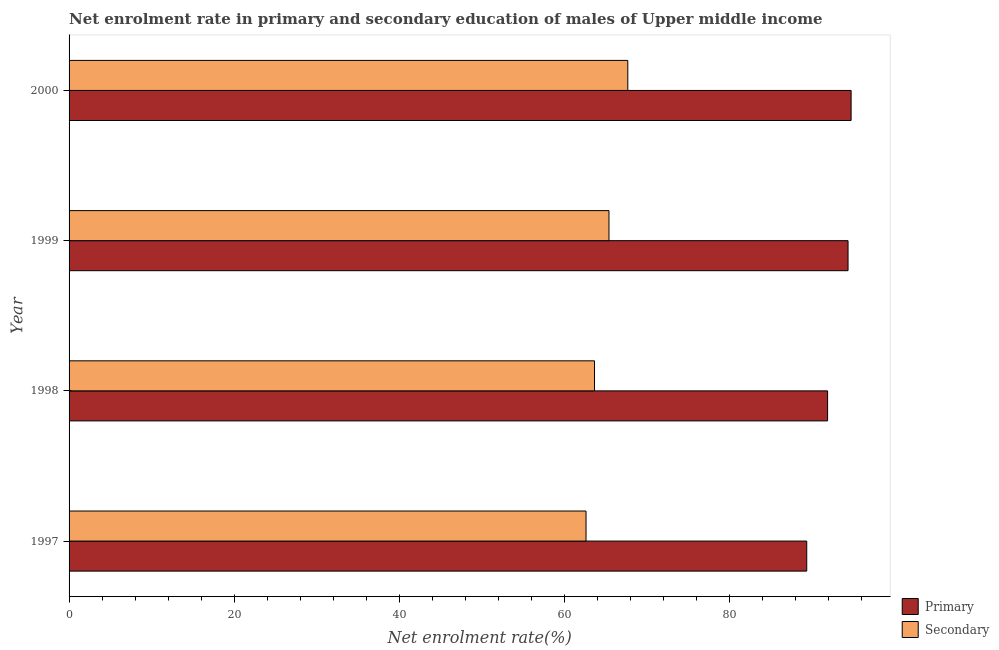How many different coloured bars are there?
Provide a short and direct response. 2. Are the number of bars per tick equal to the number of legend labels?
Provide a succinct answer. Yes. How many bars are there on the 3rd tick from the bottom?
Offer a very short reply. 2. What is the label of the 2nd group of bars from the top?
Make the answer very short. 1999. What is the enrollment rate in secondary education in 1998?
Your answer should be compact. 63.63. Across all years, what is the maximum enrollment rate in secondary education?
Give a very brief answer. 67.66. Across all years, what is the minimum enrollment rate in secondary education?
Provide a succinct answer. 62.6. In which year was the enrollment rate in primary education maximum?
Your answer should be compact. 2000. What is the total enrollment rate in primary education in the graph?
Your response must be concise. 370.21. What is the difference between the enrollment rate in primary education in 1998 and that in 2000?
Provide a succinct answer. -2.85. What is the difference between the enrollment rate in primary education in 2000 and the enrollment rate in secondary education in 1999?
Give a very brief answer. 29.32. What is the average enrollment rate in secondary education per year?
Give a very brief answer. 64.82. In the year 1998, what is the difference between the enrollment rate in secondary education and enrollment rate in primary education?
Provide a short and direct response. -28.22. In how many years, is the enrollment rate in secondary education greater than 20 %?
Provide a succinct answer. 4. Is the enrollment rate in primary education in 1998 less than that in 1999?
Your answer should be very brief. Yes. What is the difference between the highest and the second highest enrollment rate in primary education?
Your response must be concise. 0.37. What is the difference between the highest and the lowest enrollment rate in secondary education?
Your answer should be compact. 5.06. What does the 1st bar from the top in 1999 represents?
Your answer should be compact. Secondary. What does the 2nd bar from the bottom in 1999 represents?
Ensure brevity in your answer.  Secondary. How many years are there in the graph?
Your answer should be very brief. 4. What is the difference between two consecutive major ticks on the X-axis?
Keep it short and to the point. 20. Are the values on the major ticks of X-axis written in scientific E-notation?
Your answer should be compact. No. Does the graph contain any zero values?
Ensure brevity in your answer.  No. Where does the legend appear in the graph?
Offer a terse response. Bottom right. How are the legend labels stacked?
Provide a succinct answer. Vertical. What is the title of the graph?
Give a very brief answer. Net enrolment rate in primary and secondary education of males of Upper middle income. What is the label or title of the X-axis?
Your answer should be very brief. Net enrolment rate(%). What is the Net enrolment rate(%) in Primary in 1997?
Your response must be concise. 89.33. What is the Net enrolment rate(%) of Secondary in 1997?
Make the answer very short. 62.6. What is the Net enrolment rate(%) in Primary in 1998?
Give a very brief answer. 91.85. What is the Net enrolment rate(%) in Secondary in 1998?
Offer a very short reply. 63.63. What is the Net enrolment rate(%) of Primary in 1999?
Offer a very short reply. 94.33. What is the Net enrolment rate(%) in Secondary in 1999?
Give a very brief answer. 65.38. What is the Net enrolment rate(%) in Primary in 2000?
Your answer should be compact. 94.7. What is the Net enrolment rate(%) of Secondary in 2000?
Your response must be concise. 67.66. Across all years, what is the maximum Net enrolment rate(%) in Primary?
Offer a very short reply. 94.7. Across all years, what is the maximum Net enrolment rate(%) of Secondary?
Give a very brief answer. 67.66. Across all years, what is the minimum Net enrolment rate(%) of Primary?
Your answer should be compact. 89.33. Across all years, what is the minimum Net enrolment rate(%) in Secondary?
Keep it short and to the point. 62.6. What is the total Net enrolment rate(%) in Primary in the graph?
Ensure brevity in your answer.  370.21. What is the total Net enrolment rate(%) of Secondary in the graph?
Provide a short and direct response. 259.27. What is the difference between the Net enrolment rate(%) of Primary in 1997 and that in 1998?
Your response must be concise. -2.53. What is the difference between the Net enrolment rate(%) in Secondary in 1997 and that in 1998?
Ensure brevity in your answer.  -1.03. What is the difference between the Net enrolment rate(%) of Primary in 1997 and that in 1999?
Provide a short and direct response. -5. What is the difference between the Net enrolment rate(%) of Secondary in 1997 and that in 1999?
Your answer should be very brief. -2.78. What is the difference between the Net enrolment rate(%) of Primary in 1997 and that in 2000?
Ensure brevity in your answer.  -5.37. What is the difference between the Net enrolment rate(%) in Secondary in 1997 and that in 2000?
Give a very brief answer. -5.06. What is the difference between the Net enrolment rate(%) in Primary in 1998 and that in 1999?
Provide a succinct answer. -2.48. What is the difference between the Net enrolment rate(%) in Secondary in 1998 and that in 1999?
Keep it short and to the point. -1.75. What is the difference between the Net enrolment rate(%) in Primary in 1998 and that in 2000?
Ensure brevity in your answer.  -2.85. What is the difference between the Net enrolment rate(%) in Secondary in 1998 and that in 2000?
Your response must be concise. -4.03. What is the difference between the Net enrolment rate(%) in Primary in 1999 and that in 2000?
Offer a very short reply. -0.37. What is the difference between the Net enrolment rate(%) of Secondary in 1999 and that in 2000?
Provide a short and direct response. -2.28. What is the difference between the Net enrolment rate(%) in Primary in 1997 and the Net enrolment rate(%) in Secondary in 1998?
Your answer should be compact. 25.7. What is the difference between the Net enrolment rate(%) of Primary in 1997 and the Net enrolment rate(%) of Secondary in 1999?
Make the answer very short. 23.95. What is the difference between the Net enrolment rate(%) of Primary in 1997 and the Net enrolment rate(%) of Secondary in 2000?
Provide a succinct answer. 21.67. What is the difference between the Net enrolment rate(%) of Primary in 1998 and the Net enrolment rate(%) of Secondary in 1999?
Your answer should be very brief. 26.47. What is the difference between the Net enrolment rate(%) of Primary in 1998 and the Net enrolment rate(%) of Secondary in 2000?
Your answer should be compact. 24.19. What is the difference between the Net enrolment rate(%) in Primary in 1999 and the Net enrolment rate(%) in Secondary in 2000?
Offer a very short reply. 26.67. What is the average Net enrolment rate(%) of Primary per year?
Offer a very short reply. 92.55. What is the average Net enrolment rate(%) of Secondary per year?
Ensure brevity in your answer.  64.82. In the year 1997, what is the difference between the Net enrolment rate(%) of Primary and Net enrolment rate(%) of Secondary?
Offer a terse response. 26.73. In the year 1998, what is the difference between the Net enrolment rate(%) of Primary and Net enrolment rate(%) of Secondary?
Your answer should be very brief. 28.22. In the year 1999, what is the difference between the Net enrolment rate(%) of Primary and Net enrolment rate(%) of Secondary?
Give a very brief answer. 28.95. In the year 2000, what is the difference between the Net enrolment rate(%) in Primary and Net enrolment rate(%) in Secondary?
Give a very brief answer. 27.04. What is the ratio of the Net enrolment rate(%) of Primary in 1997 to that in 1998?
Offer a very short reply. 0.97. What is the ratio of the Net enrolment rate(%) in Secondary in 1997 to that in 1998?
Offer a very short reply. 0.98. What is the ratio of the Net enrolment rate(%) in Primary in 1997 to that in 1999?
Ensure brevity in your answer.  0.95. What is the ratio of the Net enrolment rate(%) in Secondary in 1997 to that in 1999?
Make the answer very short. 0.96. What is the ratio of the Net enrolment rate(%) of Primary in 1997 to that in 2000?
Give a very brief answer. 0.94. What is the ratio of the Net enrolment rate(%) in Secondary in 1997 to that in 2000?
Your response must be concise. 0.93. What is the ratio of the Net enrolment rate(%) of Primary in 1998 to that in 1999?
Ensure brevity in your answer.  0.97. What is the ratio of the Net enrolment rate(%) of Secondary in 1998 to that in 1999?
Your response must be concise. 0.97. What is the ratio of the Net enrolment rate(%) of Primary in 1998 to that in 2000?
Offer a terse response. 0.97. What is the ratio of the Net enrolment rate(%) of Secondary in 1998 to that in 2000?
Offer a terse response. 0.94. What is the ratio of the Net enrolment rate(%) of Primary in 1999 to that in 2000?
Keep it short and to the point. 1. What is the ratio of the Net enrolment rate(%) of Secondary in 1999 to that in 2000?
Provide a succinct answer. 0.97. What is the difference between the highest and the second highest Net enrolment rate(%) of Primary?
Offer a very short reply. 0.37. What is the difference between the highest and the second highest Net enrolment rate(%) in Secondary?
Ensure brevity in your answer.  2.28. What is the difference between the highest and the lowest Net enrolment rate(%) of Primary?
Your answer should be very brief. 5.37. What is the difference between the highest and the lowest Net enrolment rate(%) in Secondary?
Offer a very short reply. 5.06. 